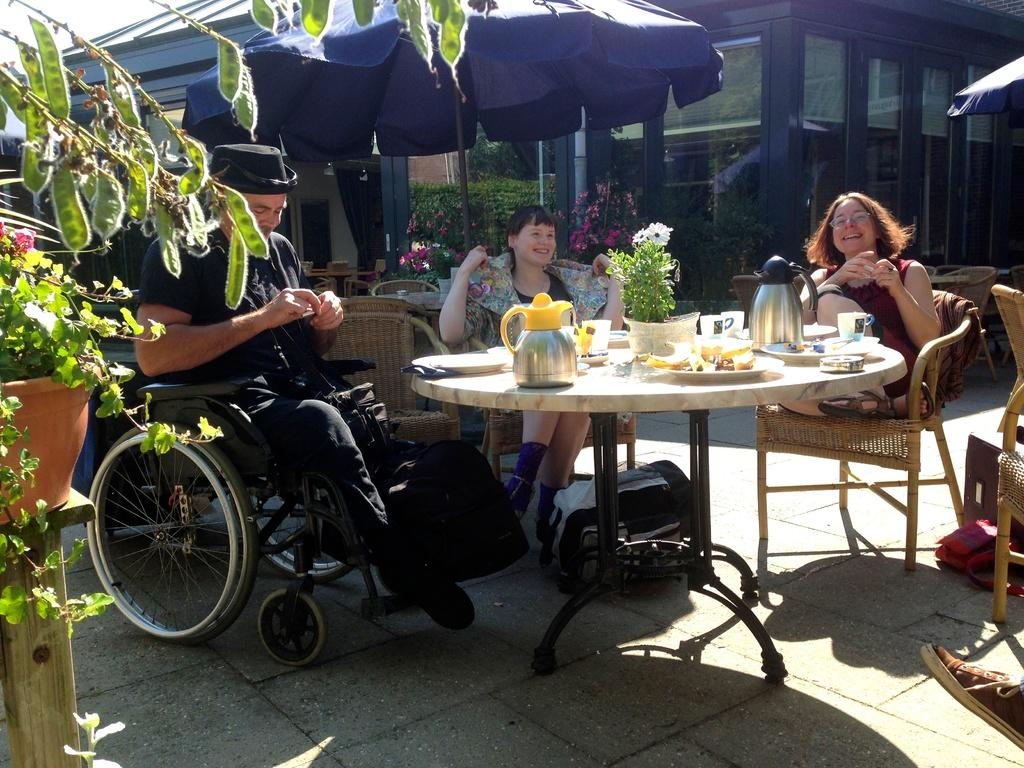What are the people in the image doing? The people in the image are sitting on chairs. Can you describe the man in the image? There is a man sitting on a wheelchair in the image. What is on the table in the image? There is a water jug on the table in the image. What else can be seen on the table? There are plates with food items on the table. What else is present in the image? There are cups in the image. What type of magic trick is the man performing with his body in the image? There is no magic trick or any indication of a body performance in the image; the man is simply sitting on a wheelchair. Can you explain how the addition of more chairs would change the image? The image would show more people sitting on chairs if additional chairs were added, but the provided facts do not mention any specific number of chairs or people. 